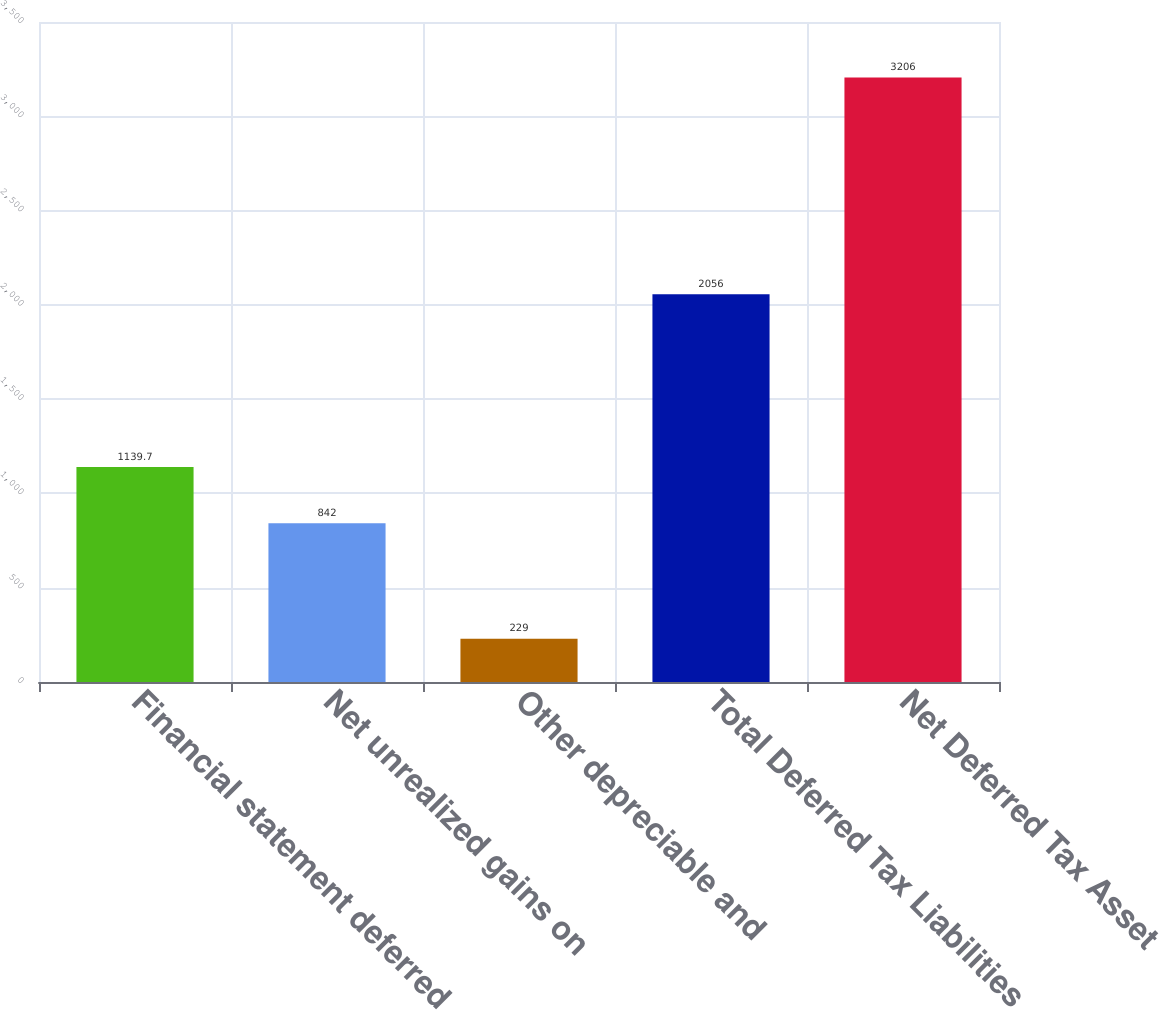<chart> <loc_0><loc_0><loc_500><loc_500><bar_chart><fcel>Financial statement deferred<fcel>Net unrealized gains on<fcel>Other depreciable and<fcel>Total Deferred Tax Liabilities<fcel>Net Deferred Tax Asset<nl><fcel>1139.7<fcel>842<fcel>229<fcel>2056<fcel>3206<nl></chart> 